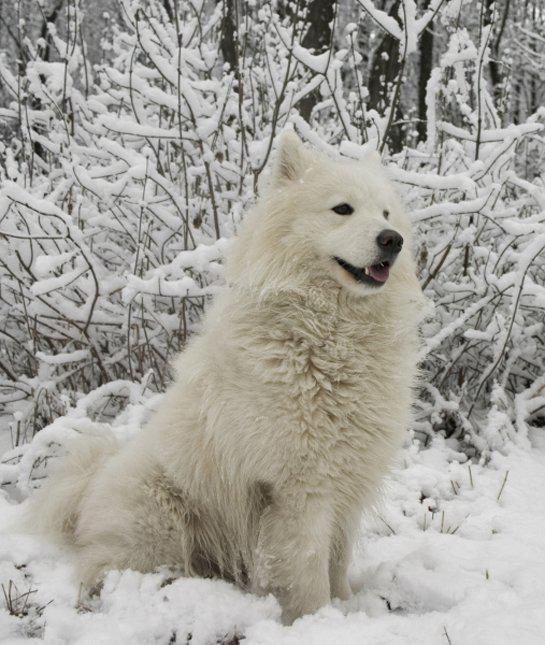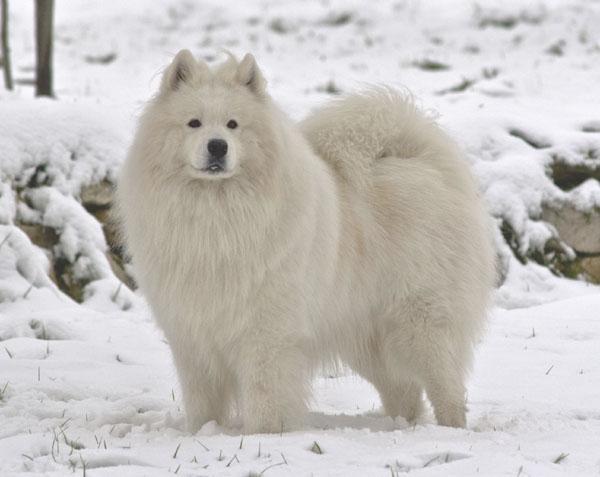The first image is the image on the left, the second image is the image on the right. Considering the images on both sides, is "One image shows two white dogs close together in the snow, and the other shows a single white dog in a snowy scene." valid? Answer yes or no. No. The first image is the image on the left, the second image is the image on the right. Analyze the images presented: Is the assertion "There are exactly three dogs." valid? Answer yes or no. No. 